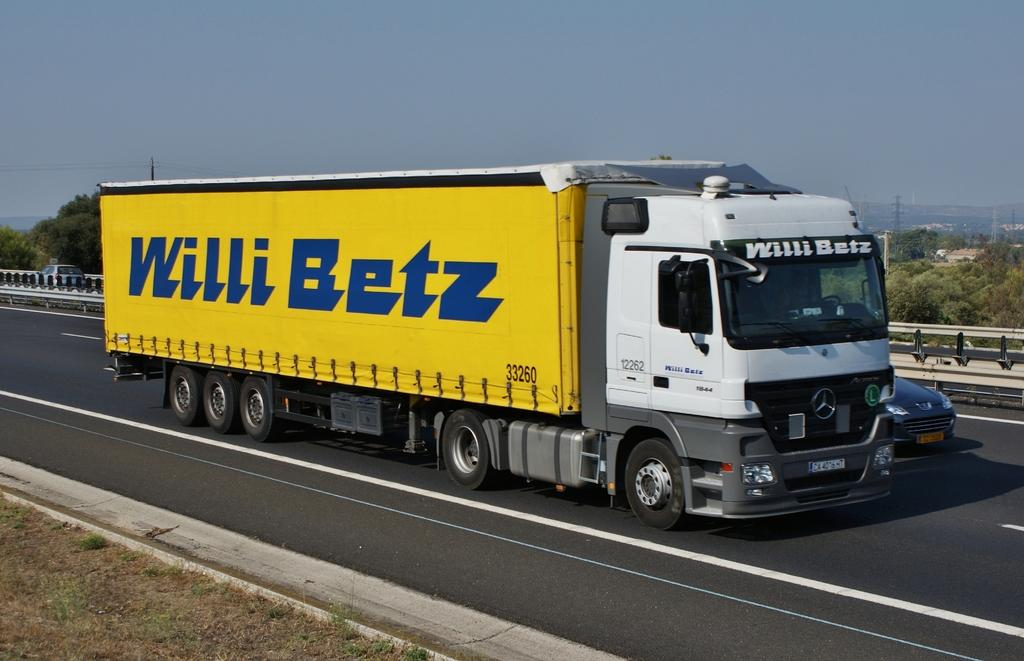What can be seen on the road in the image? There are vehicles on the road in the image. What is located beside the road in the image? There is a fence beside the road in the image. What type of natural elements can be seen in the background of the image? There are trees in the background of the image. What type of structures can be seen in the background of the image? There are towers in the background of the image. Can you see a frame hanging on the fence in the image? There is no frame hanging on the fence in the image. Are there any socks visible on the vehicles in the image? There are no socks visible on the vehicles in the image. 